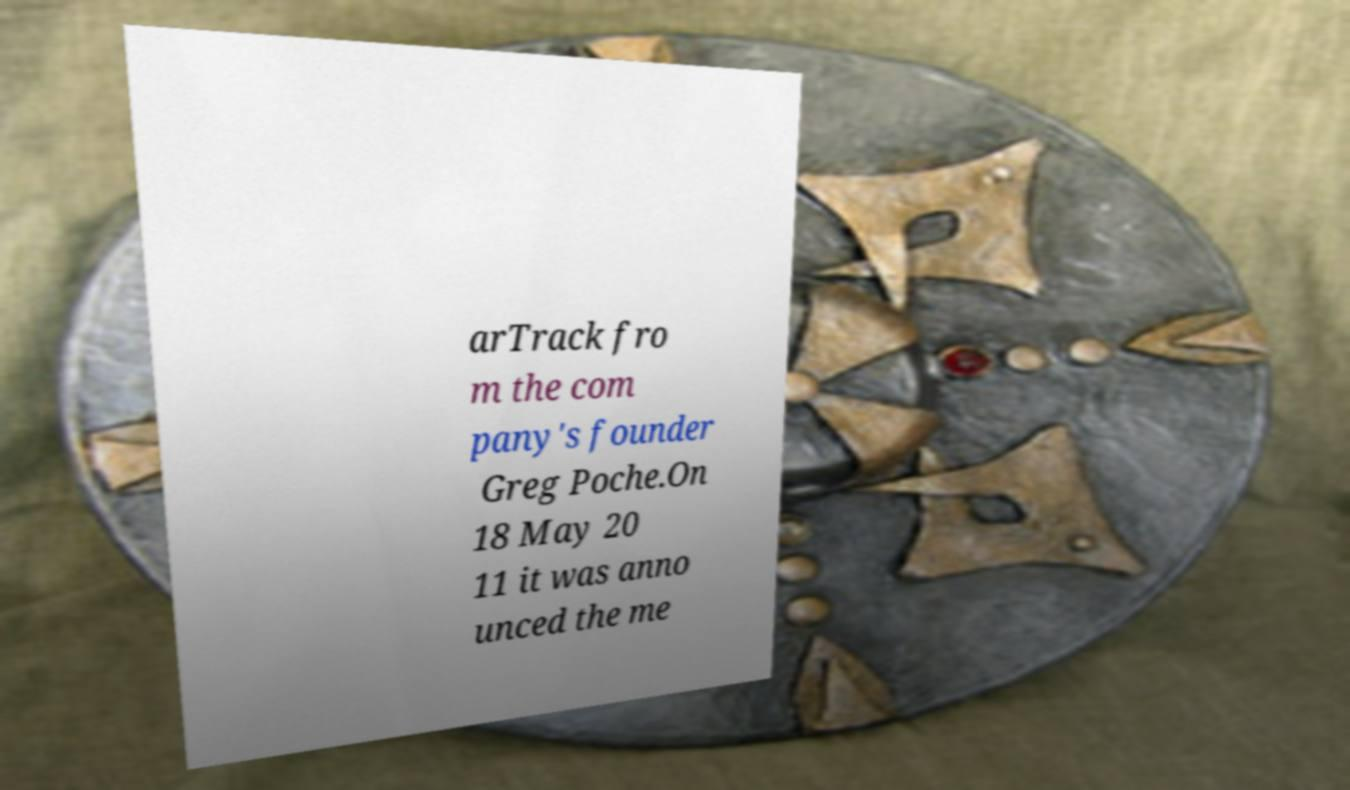Can you read and provide the text displayed in the image?This photo seems to have some interesting text. Can you extract and type it out for me? arTrack fro m the com pany's founder Greg Poche.On 18 May 20 11 it was anno unced the me 